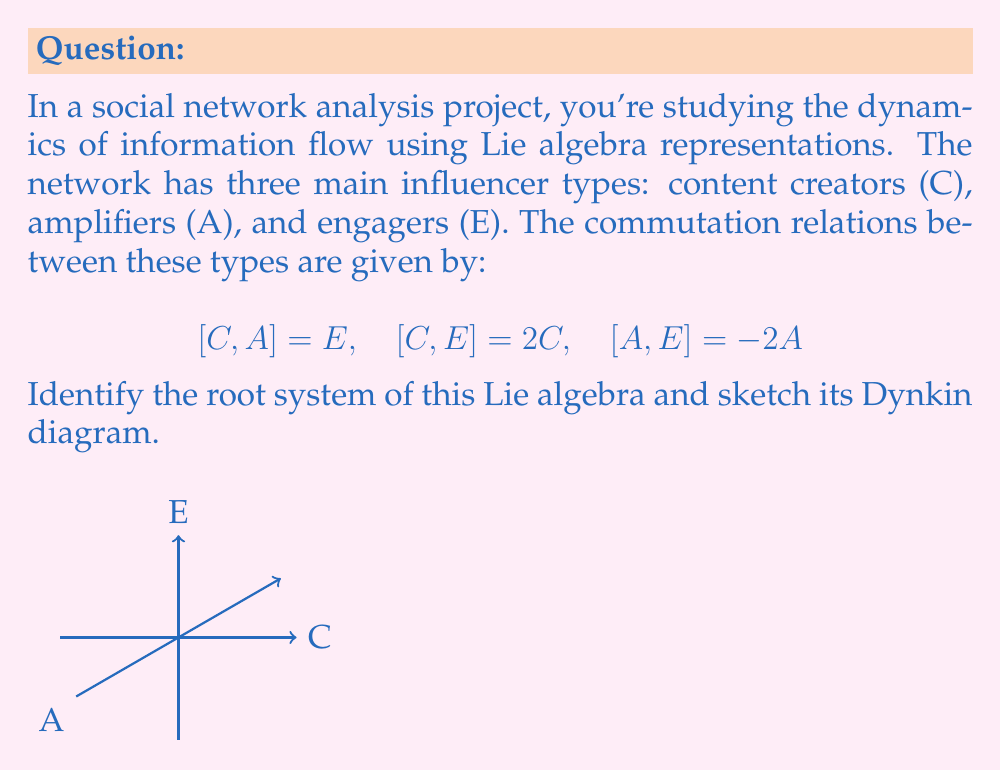Teach me how to tackle this problem. To identify the root system and sketch the Dynkin diagram, we'll follow these steps:

1) First, we recognize that this is a 3-dimensional Lie algebra with basis {C, A, E}.

2) The commutation relations given correspond to the structure constants of the Lie algebra. We can identify this as the special linear algebra $\mathfrak{sl}(2, \mathbb{C})$.

3) For $\mathfrak{sl}(2, \mathbb{C})$, we have a Cartan subalgebra $\mathfrak{h}$ spanned by E. The root space decomposition is:

   $$\mathfrak{g} = \mathfrak{g}_{-\alpha} \oplus \mathfrak{h} \oplus \mathfrak{g}_{\alpha}$$

   where $\mathfrak{g}_{-\alpha}$ is spanned by A, and $\mathfrak{g}_{\alpha}$ is spanned by C.

4) The root system consists of two roots: $\{\alpha, -\alpha\}$. These roots lie on a 1-dimensional real space $\mathfrak{h}^*$.

5) There is only one simple root in this system, which we can choose to be $\alpha$.

6) The Dynkin diagram for a rank-1 root system is simply a single node:

   [asy]
   unitsize(0.5cm);
   fill(circle((0,0),0.3), white);
   draw(circle((0,0),0.3));
   [/asy]

This Dynkin diagram represents the $A_1$ root system, which corresponds to $\mathfrak{sl}(2, \mathbb{C})$.
Answer: $A_1$ root system; Dynkin diagram: single node 